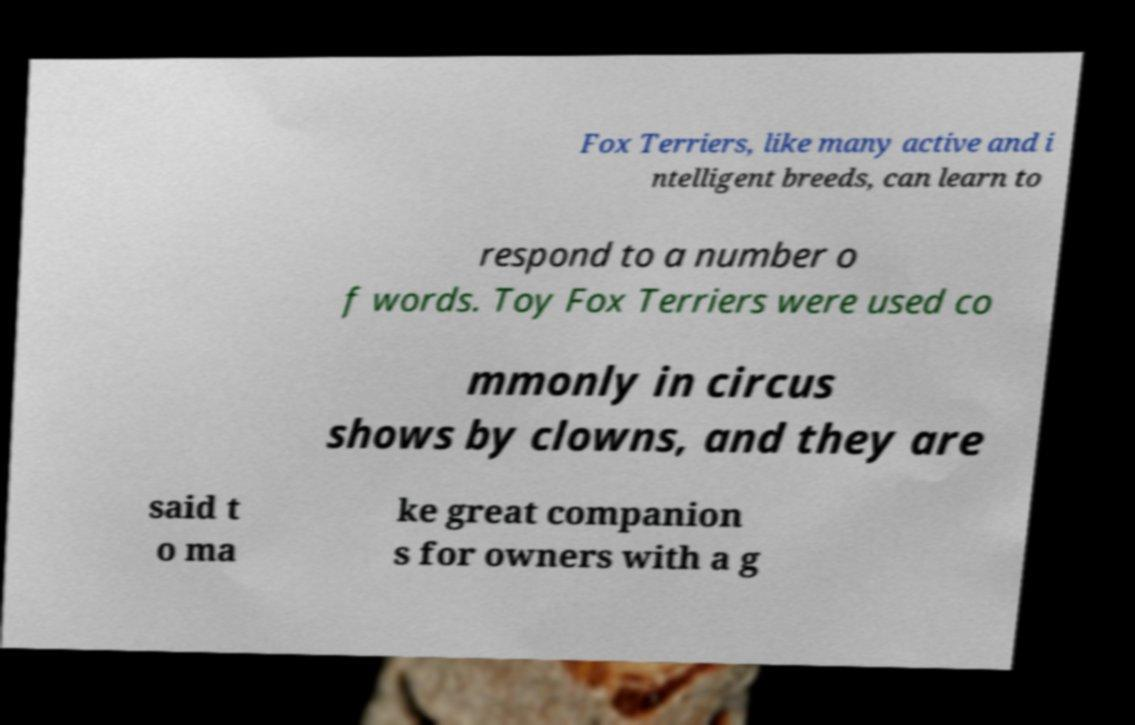What messages or text are displayed in this image? I need them in a readable, typed format. Fox Terriers, like many active and i ntelligent breeds, can learn to respond to a number o f words. Toy Fox Terriers were used co mmonly in circus shows by clowns, and they are said t o ma ke great companion s for owners with a g 